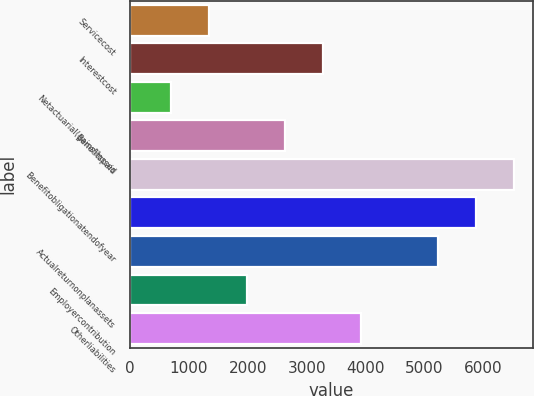<chart> <loc_0><loc_0><loc_500><loc_500><bar_chart><fcel>Servicecost<fcel>Interestcost<fcel>Netactuarial(gains)losses<fcel>Benefitspaid<fcel>Benefitobligationatendofyear<fcel>Unnamed: 5<fcel>Actualreturnonplanassets<fcel>Employercontribution<fcel>Otherliabilities<nl><fcel>1340<fcel>3282.5<fcel>692.5<fcel>2635<fcel>6520<fcel>5872.5<fcel>5225<fcel>1987.5<fcel>3930<nl></chart> 